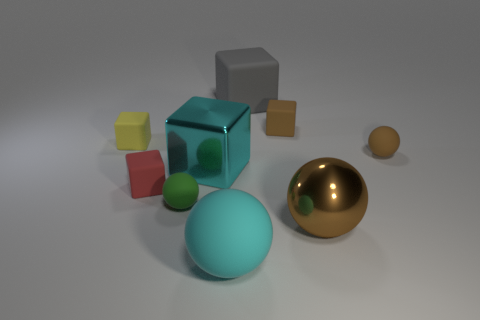Subtract all green cylinders. How many brown spheres are left? 2 Subtract all yellow blocks. How many blocks are left? 4 Subtract all big brown shiny spheres. How many spheres are left? 3 Subtract 1 balls. How many balls are left? 3 Add 1 yellow blocks. How many objects exist? 10 Subtract all yellow cubes. Subtract all purple balls. How many cubes are left? 4 Subtract all cubes. How many objects are left? 4 Subtract all rubber blocks. Subtract all small red rubber cubes. How many objects are left? 4 Add 7 green spheres. How many green spheres are left? 8 Add 7 brown things. How many brown things exist? 10 